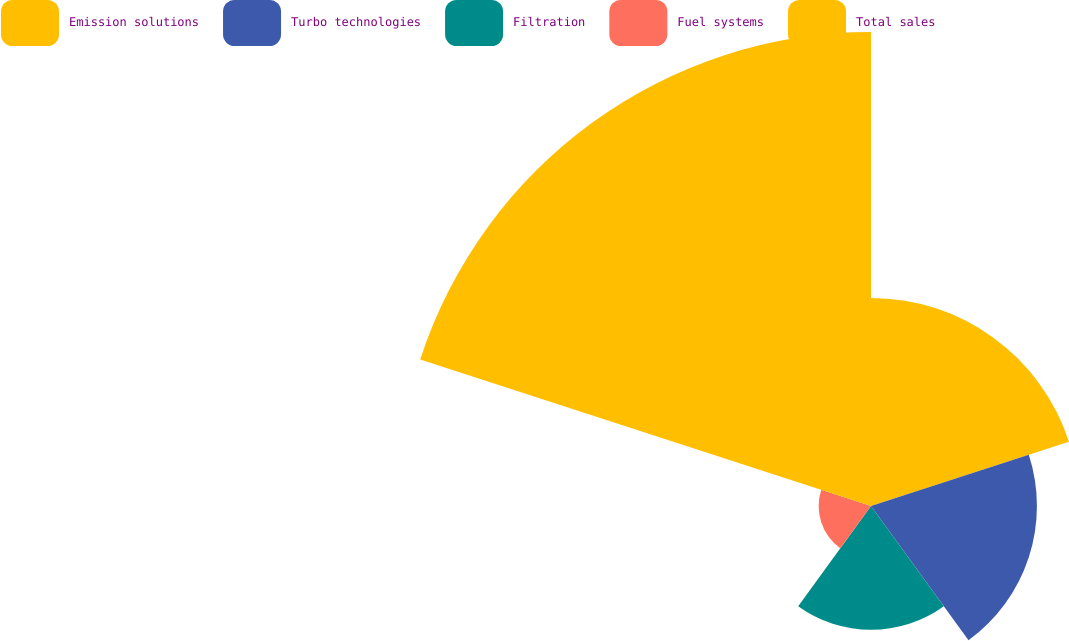Convert chart. <chart><loc_0><loc_0><loc_500><loc_500><pie_chart><fcel>Emission solutions<fcel>Turbo technologies<fcel>Filtration<fcel>Fuel systems<fcel>Total sales<nl><fcel>20.32%<fcel>16.2%<fcel>12.09%<fcel>5.11%<fcel>46.28%<nl></chart> 